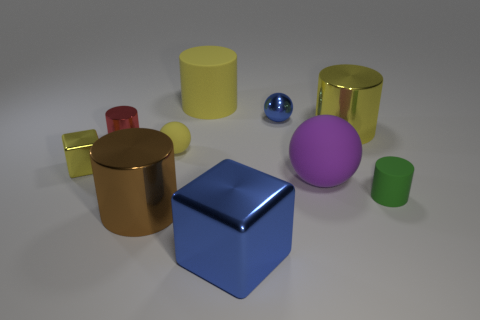Subtract all tiny rubber spheres. How many spheres are left? 2 Subtract all brown cubes. How many yellow cylinders are left? 2 Subtract all brown cylinders. How many cylinders are left? 4 Subtract 1 blocks. How many blocks are left? 1 Add 3 red things. How many red things are left? 4 Add 3 big blue matte things. How many big blue matte things exist? 3 Subtract 0 gray cubes. How many objects are left? 10 Subtract all balls. How many objects are left? 7 Subtract all brown balls. Subtract all red cubes. How many balls are left? 3 Subtract all yellow spheres. Subtract all shiny spheres. How many objects are left? 8 